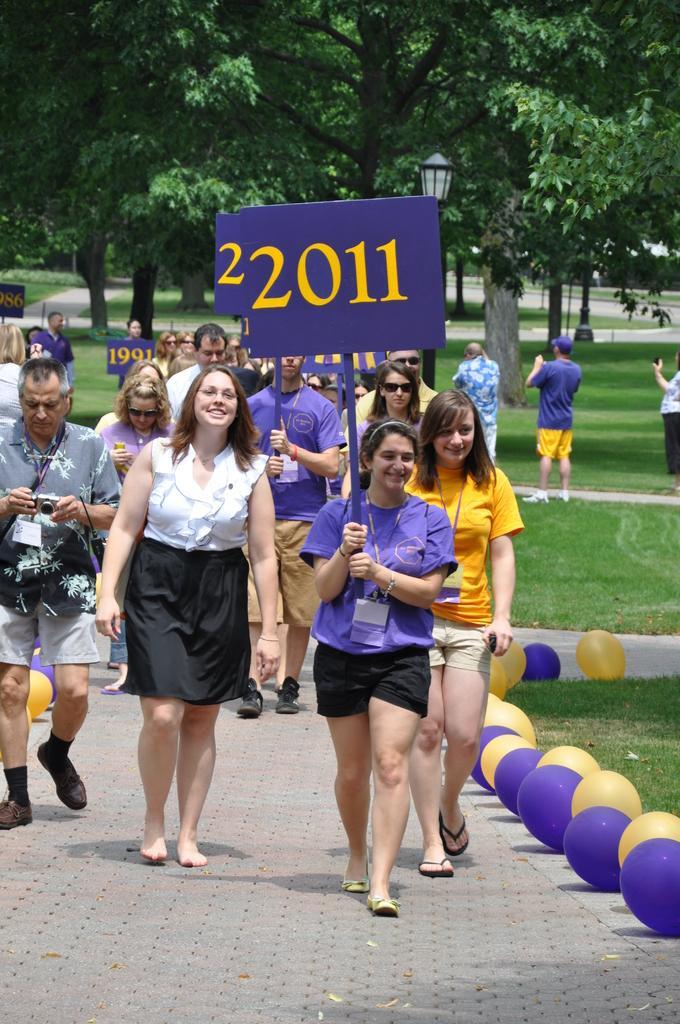In one or two sentences, can you explain what this image depicts? In this image few persons are walking on the path having different colors of balloons at the border of path. Woman wearing a violet color shirt is holding a stick having a board. Left side a person is holding a camera in his hand. Behind him there are few balloons. Few persons are standing on the grassland. Background there are few trees. Behind these persons there is a street light. 